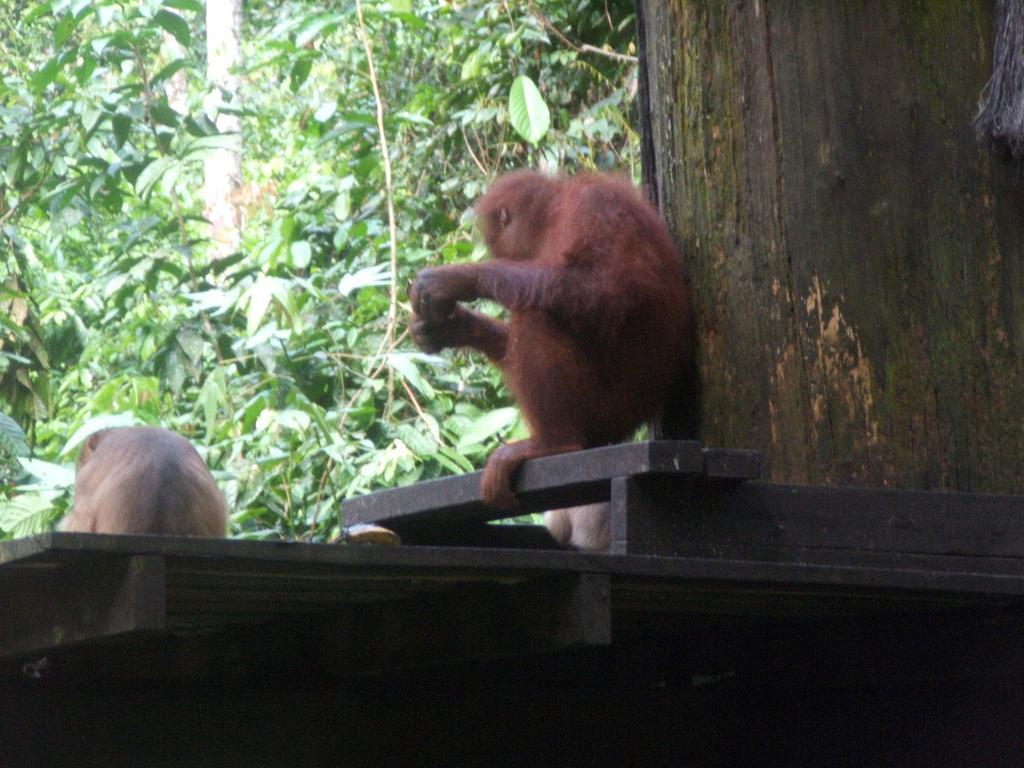How would you summarize this image in a sentence or two? In this image there are monkeys on the platform. In front of them there are trees. On the right side of the image there is a trunk of a tree. 